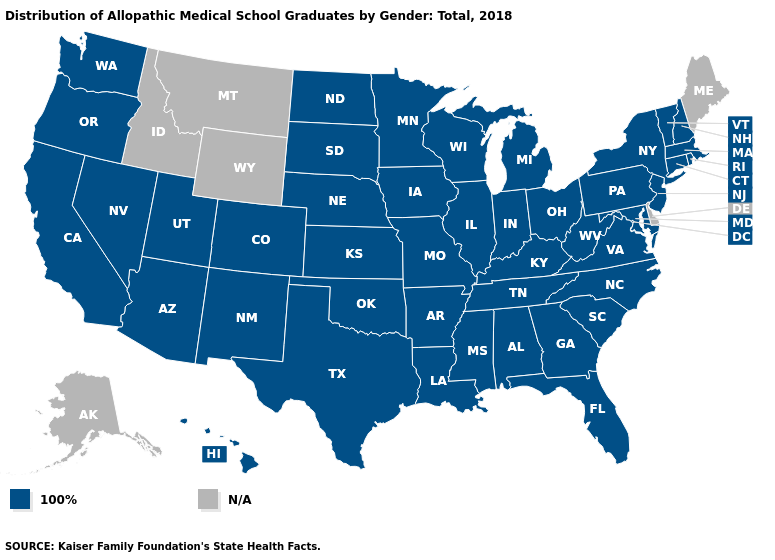Which states have the lowest value in the MidWest?
Be succinct. Illinois, Indiana, Iowa, Kansas, Michigan, Minnesota, Missouri, Nebraska, North Dakota, Ohio, South Dakota, Wisconsin. What is the value of South Dakota?
Keep it brief. 100%. What is the lowest value in states that border Louisiana?
Write a very short answer. 100%. Which states have the lowest value in the West?
Write a very short answer. Arizona, California, Colorado, Hawaii, Nevada, New Mexico, Oregon, Utah, Washington. What is the lowest value in the West?
Answer briefly. 100%. What is the lowest value in states that border Arkansas?
Short answer required. 100%. What is the value of Minnesota?
Short answer required. 100%. What is the value of Kentucky?
Write a very short answer. 100%. Does the map have missing data?
Be succinct. Yes. What is the value of Illinois?
Be succinct. 100%. 